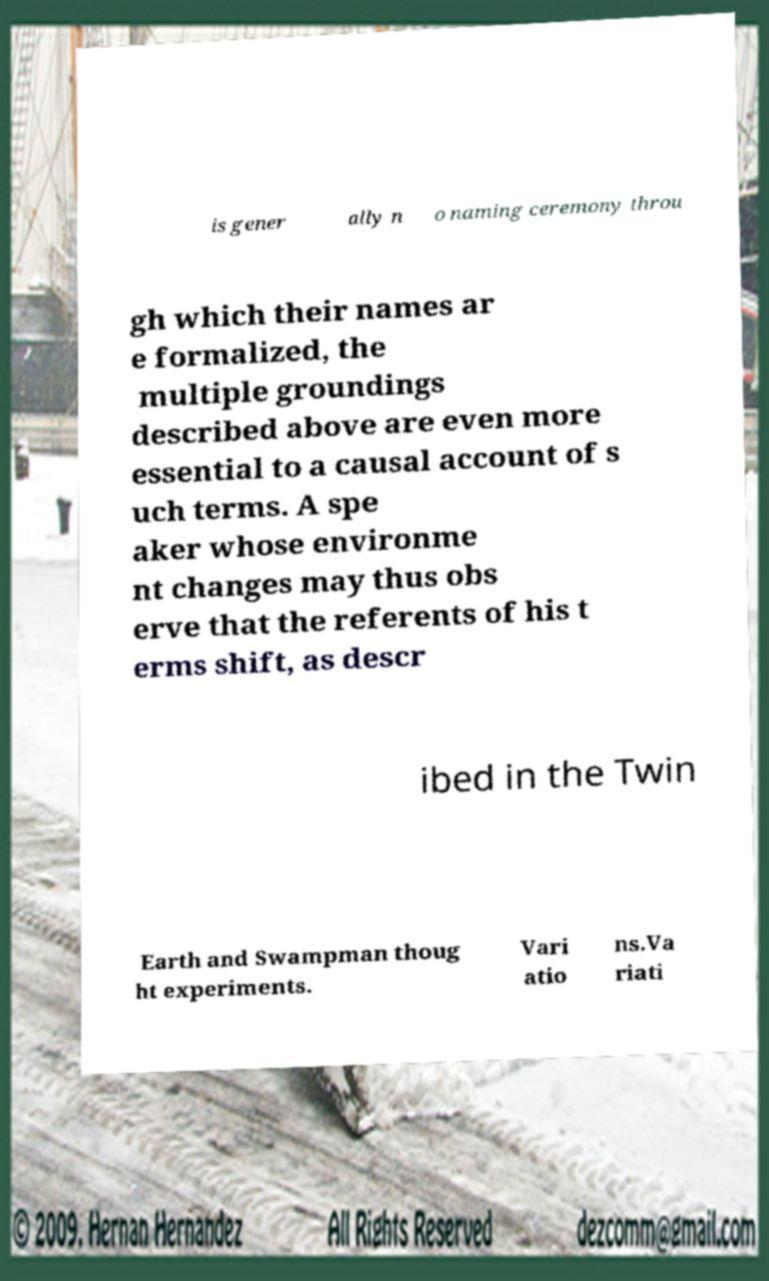Please identify and transcribe the text found in this image. is gener ally n o naming ceremony throu gh which their names ar e formalized, the multiple groundings described above are even more essential to a causal account of s uch terms. A spe aker whose environme nt changes may thus obs erve that the referents of his t erms shift, as descr ibed in the Twin Earth and Swampman thoug ht experiments. Vari atio ns.Va riati 